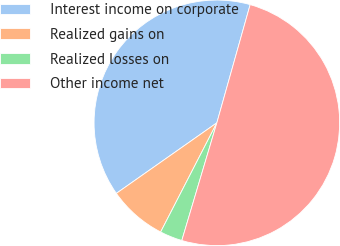Convert chart to OTSL. <chart><loc_0><loc_0><loc_500><loc_500><pie_chart><fcel>Interest income on corporate<fcel>Realized gains on<fcel>Realized losses on<fcel>Other income net<nl><fcel>39.11%<fcel>7.69%<fcel>2.96%<fcel>50.23%<nl></chart> 